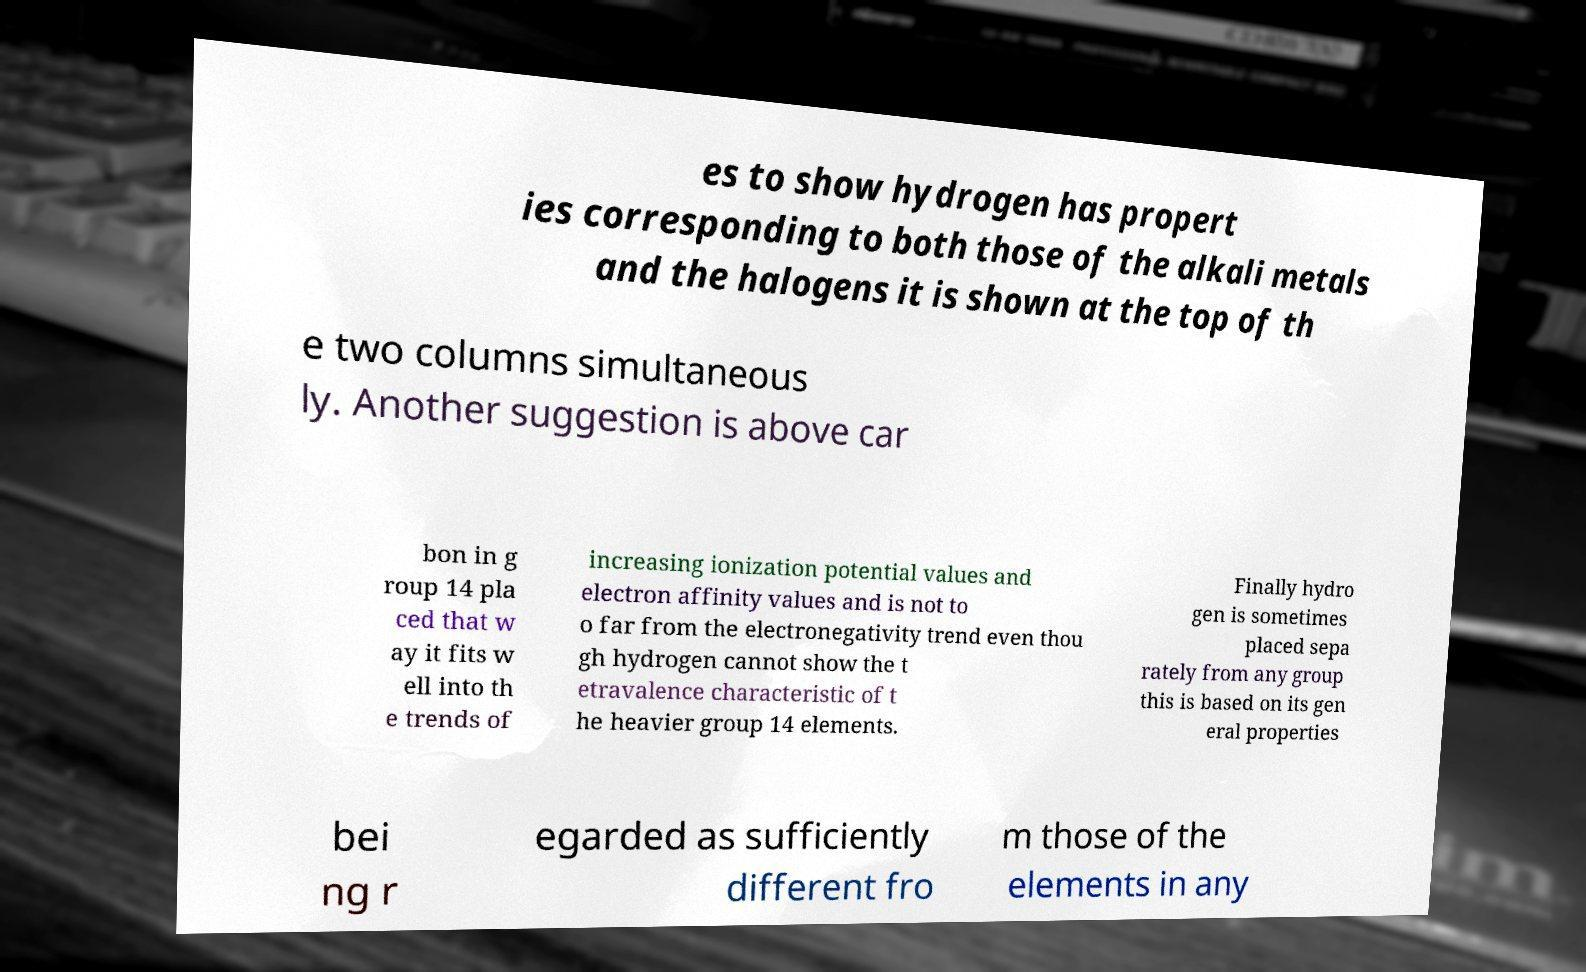There's text embedded in this image that I need extracted. Can you transcribe it verbatim? es to show hydrogen has propert ies corresponding to both those of the alkali metals and the halogens it is shown at the top of th e two columns simultaneous ly. Another suggestion is above car bon in g roup 14 pla ced that w ay it fits w ell into th e trends of increasing ionization potential values and electron affinity values and is not to o far from the electronegativity trend even thou gh hydrogen cannot show the t etravalence characteristic of t he heavier group 14 elements. Finally hydro gen is sometimes placed sepa rately from any group this is based on its gen eral properties bei ng r egarded as sufficiently different fro m those of the elements in any 